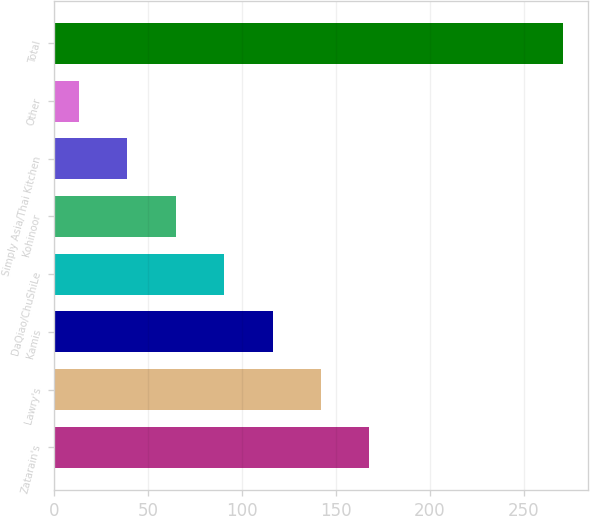Convert chart. <chart><loc_0><loc_0><loc_500><loc_500><bar_chart><fcel>Zatarain's<fcel>Lawry's<fcel>Kamis<fcel>DaQiao/ChuShiLe<fcel>Kohinoor<fcel>Simply Asia/Thai Kitchen<fcel>Other<fcel>Total<nl><fcel>167.72<fcel>141.95<fcel>116.18<fcel>90.41<fcel>64.64<fcel>38.87<fcel>13.1<fcel>270.8<nl></chart> 